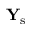<formula> <loc_0><loc_0><loc_500><loc_500>{ Y } _ { s }</formula> 